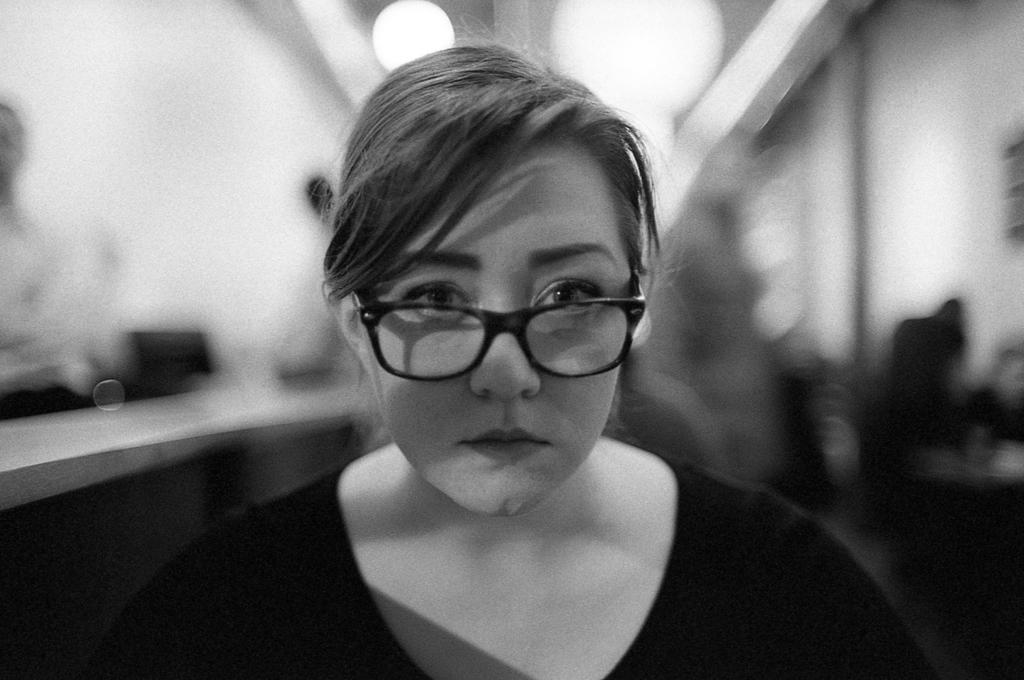What is the main subject of the image? The main subject of the image is a woman. What is the woman doing in the image? The woman is looking at the side. What type of clothing is the woman wearing? The woman is wearing a t-shirt. What accessory is the woman wearing on her face? The woman has black color spectacles. What type of letters is the ghost holding in the image? There is no ghost or letters present in the image. What advice does the woman's father give her in the image? There is no reference to the woman's father or any advice in the image. 